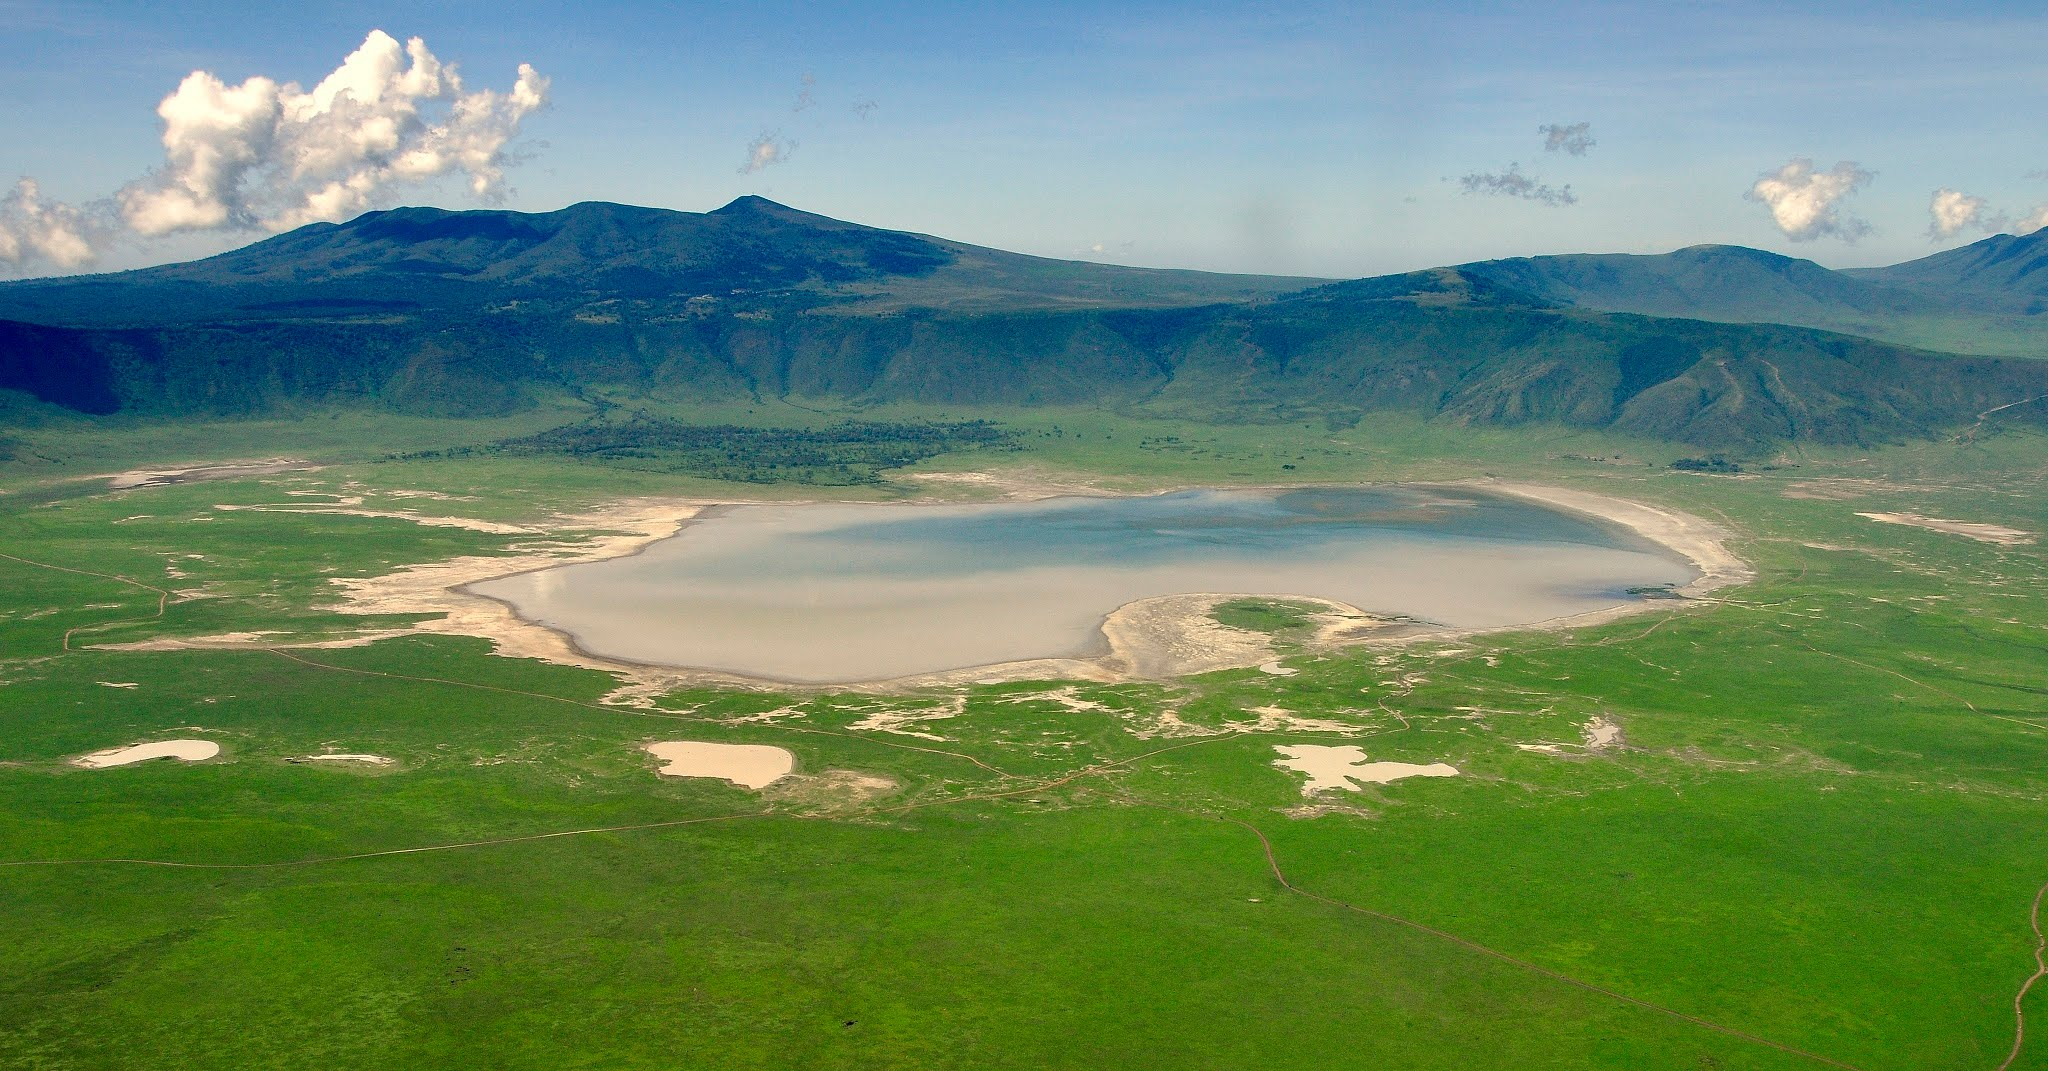Describe the ecosystem within the Ngorongoro Crater. The Ngorongoro Crater hosts one of the world’s most diverse ecosystems. Enclosed within its steep walls, a variety of habitats—such as forests, grasslands, and wetlands—support a wide range of flora and fauna. This natural enclosure is home to the 'Big Five' game animals: lions, elephants, leopards, buffalo, and rhinoceros. The crater floor's grassy plains support large herds of wildebeest, zebras, and gazelles, while the marshes and lake areas attract numerous bird species, including flamingos. Forested regions provide refuge for monkeys, baboons, and various birdlife. This unique and dynamic ecosystem offers a rare concentration of wildlife, set within the dramatic landscape of the crater. What kind of human activity is allowed within the Ngorongoro Crater? Human activity within the Ngorongoro Crater is highly regulated to preserve its pristine environment and diverse wildlife. Tourism is the primary permitted activity, with guided safaris being the most popular way for visitors to experience the crater. The Ngorongoro Conservation Area Authority strictly controls vehicle access and limits the number of tourists to reduce environmental impact. Additionally, some Maasai pastoralists are allowed to graze their cattle within the crater, under strict regulations that ensure their activities do not harm the ecosystem. Conservation efforts are ongoing to maintain the ecological balance while supporting the region's economic benefits from sustainable tourism. Imagine an ancient civilization thrived within the Ngorongoro Crater. Describe what their daily life might have been like. In an alternate history where an ancient civilization thrived within the Ngorongoro Crater, life would have been uniquely adapted to the crater’s rich and varied environment. The fertile lands and abundant water sources would support robust agricultural practices, with terraces and irrigation systems ingeniously carved into the crater's slopes to grow crops such as maize, beans, and yams. The community would also benefit from the diverse wildlife, likely developing sophisticated hunting techniques and possibly domesticating certain species for food and labor. The crater’s natural defenses—a steep rim and limited access points—would provide security, leading to a relatively peaceful existence. Rituals and cultural practices might revolve around the lake and mountains, which would be revered as sacred. The society's architecture would blend seamlessly with the environment, using local materials to build homes and communal structures that offer protection from the elements while harnessing the natural beauty and resources of the crater. 